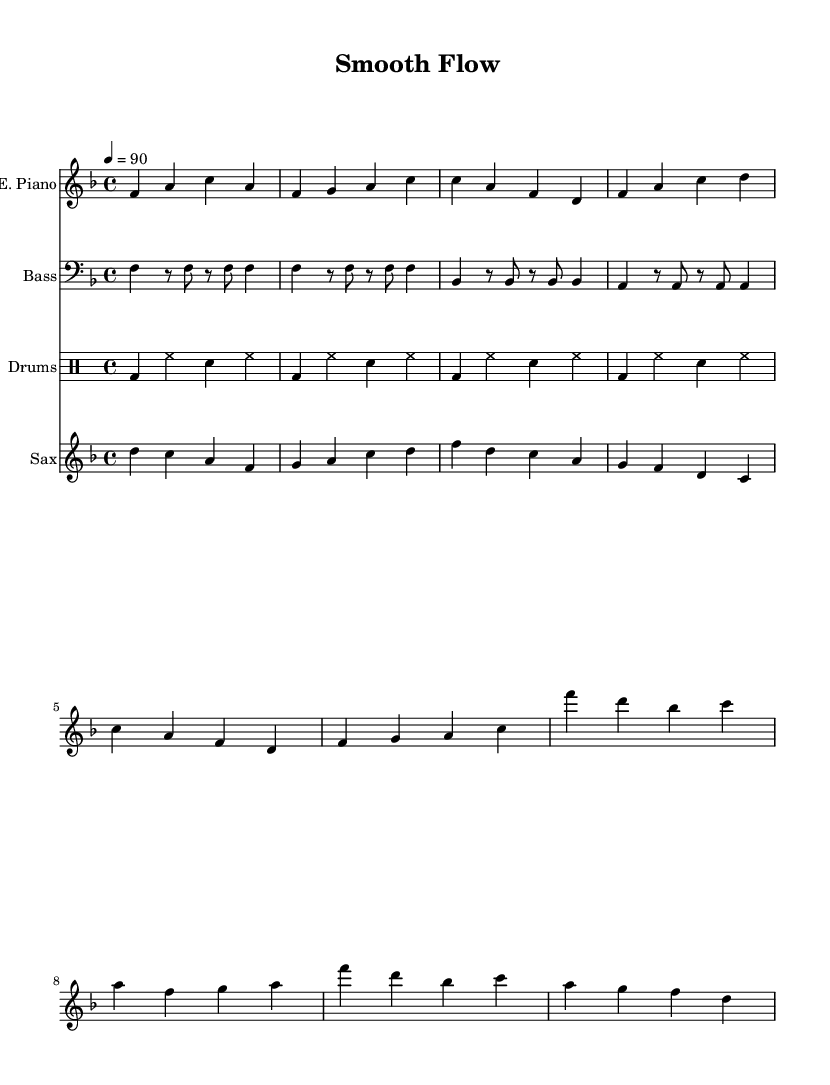What is the key signature of this music? The key signature is F major, which has one flat (B flat). This can be identified by looking at the key signature indicated at the beginning of the staff.
Answer: F major What is the time signature of this music? The time signature is 4/4, which represents four beats in a measure and a quarter note as the unit of beat. This can be seen directly in the notation at the beginning of the piece.
Answer: 4/4 What is the tempo marking of this piece? The tempo marking is 90 beats per minute, indicated in the score as "4 = 90". This is located near the beginning of the sheet music.
Answer: 90 How many measures are in the verse section? The verse section is abbreviated in this excerpt, but counting the measures in the verse line shows there are four measures. Each line has four measures of music, indicated by the bar lines.
Answer: 4 Which instrument plays the intro? The electric piano plays the intro section, as indicated by the staff labeled "E. Piano" and the notation directly below it.
Answer: Electric Piano How does the rhythm of the bass guitar compare to the electric piano in the verse? The bass guitar provides a syncopated rhythm compared to the steady rhythm of the electric piano. The bass guitar alternates between long and short notes, while the electric piano has a more straightforward note pattern in the verse section. This can be analyzed by examining the note lengths and patterns in both parts.
Answer: Syncopated What musical element is emphasized by the saxophone part in the bridge section? The saxophone part emphasizes melodic continuity, creating a smooth flow and connecting phrases in the bridge, which can be observed by the phrase structure and the movement of pitches in the saxophone staff.
Answer: Melodic continuity 